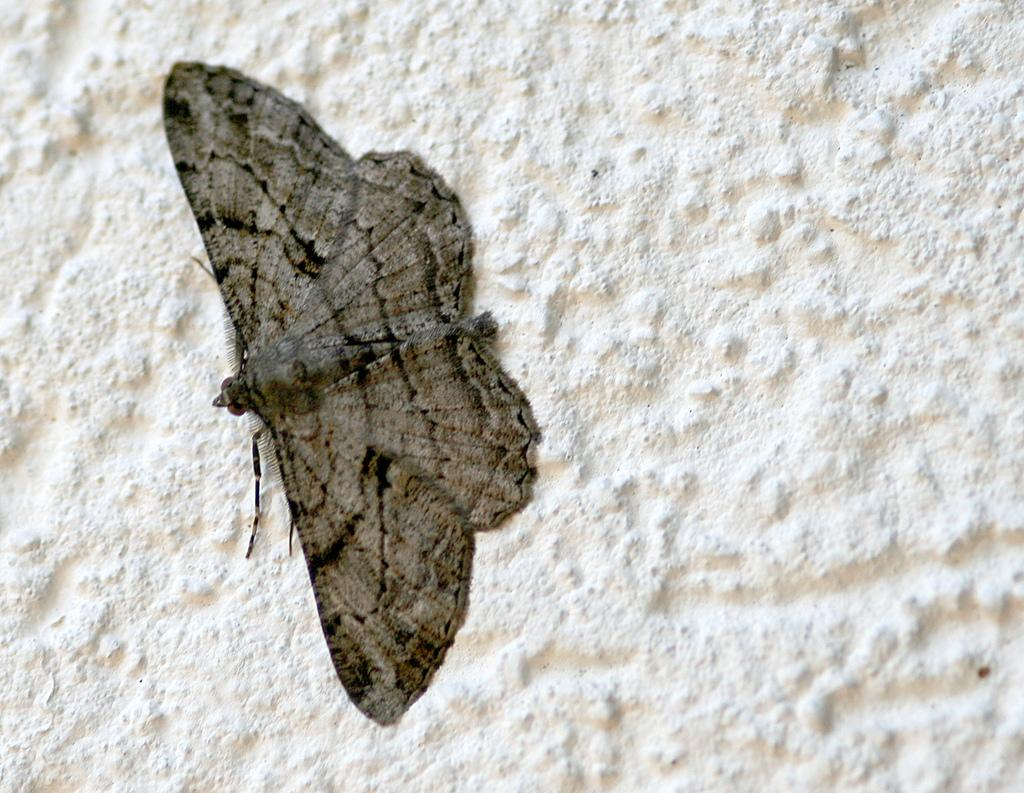What is present on the wall in the image? There is an insect on the wall in the image. What is the color of the wall? The wall is white in color. Can you describe the insect's location on the wall? The insect is on the wall in the image. What type of noise is the bat making in the image? There is no bat present in the image, so it is not possible to determine what noise it might be making. 